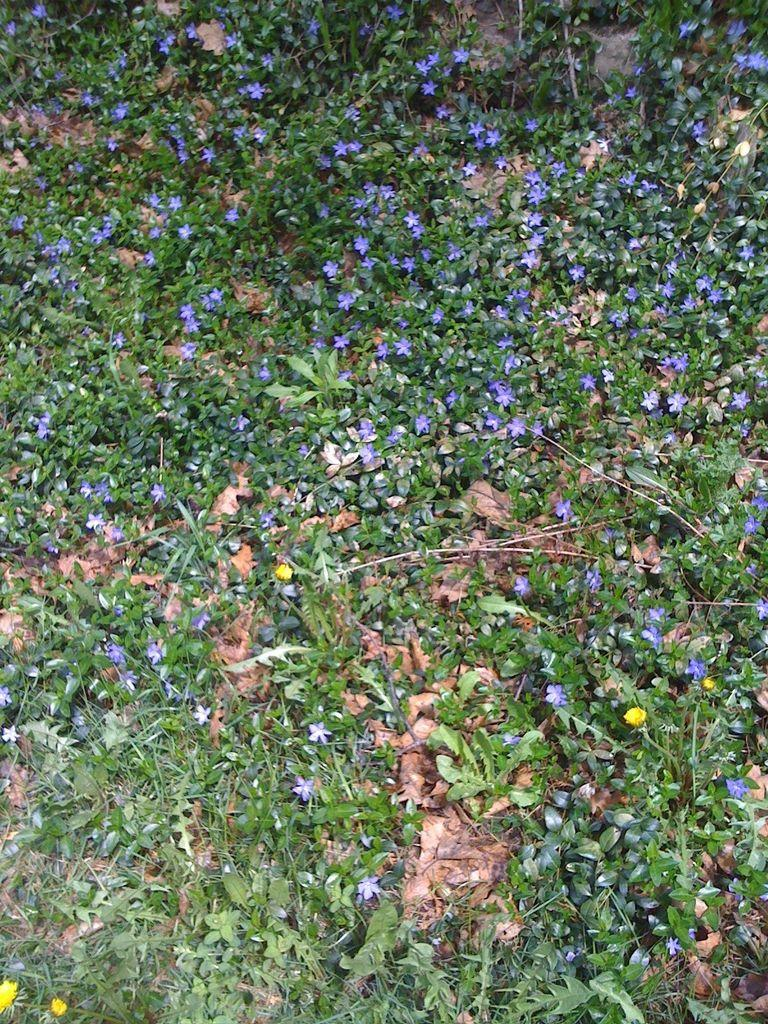What types of vegetation can be seen in the image? There are plants and flowers in the image. Are there any fallen leaves in the image? Yes, there are dried leaves in the image. What type of bubble can be seen in the image? There is no bubble present in the image. What meal is being prepared in the image? There is no meal preparation depicted in the image; it features plants, flowers, and dried leaves. 